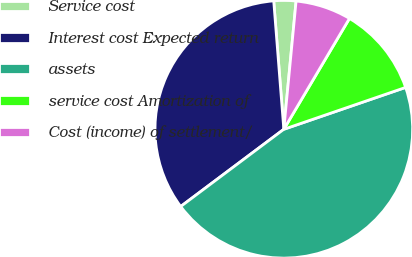<chart> <loc_0><loc_0><loc_500><loc_500><pie_chart><fcel>Service cost<fcel>Interest cost Expected return<fcel>assets<fcel>service cost Amortization of<fcel>Cost (income) of settlement/<nl><fcel>2.77%<fcel>33.98%<fcel>45.04%<fcel>11.22%<fcel>6.99%<nl></chart> 